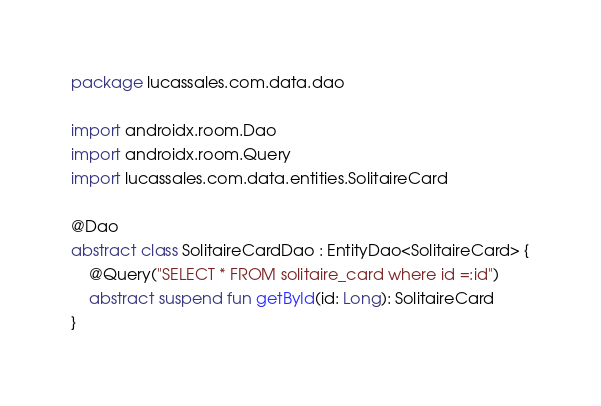<code> <loc_0><loc_0><loc_500><loc_500><_Kotlin_>package lucassales.com.data.dao

import androidx.room.Dao
import androidx.room.Query
import lucassales.com.data.entities.SolitaireCard

@Dao
abstract class SolitaireCardDao : EntityDao<SolitaireCard> {
    @Query("SELECT * FROM solitaire_card where id =:id")
    abstract suspend fun getById(id: Long): SolitaireCard
}</code> 